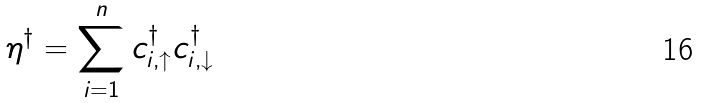Convert formula to latex. <formula><loc_0><loc_0><loc_500><loc_500>\eta ^ { \dagger } = \sum _ { i = 1 } ^ { n } c ^ { \dagger } _ { i , \uparrow } c ^ { \dagger } _ { i , \downarrow } \,</formula> 